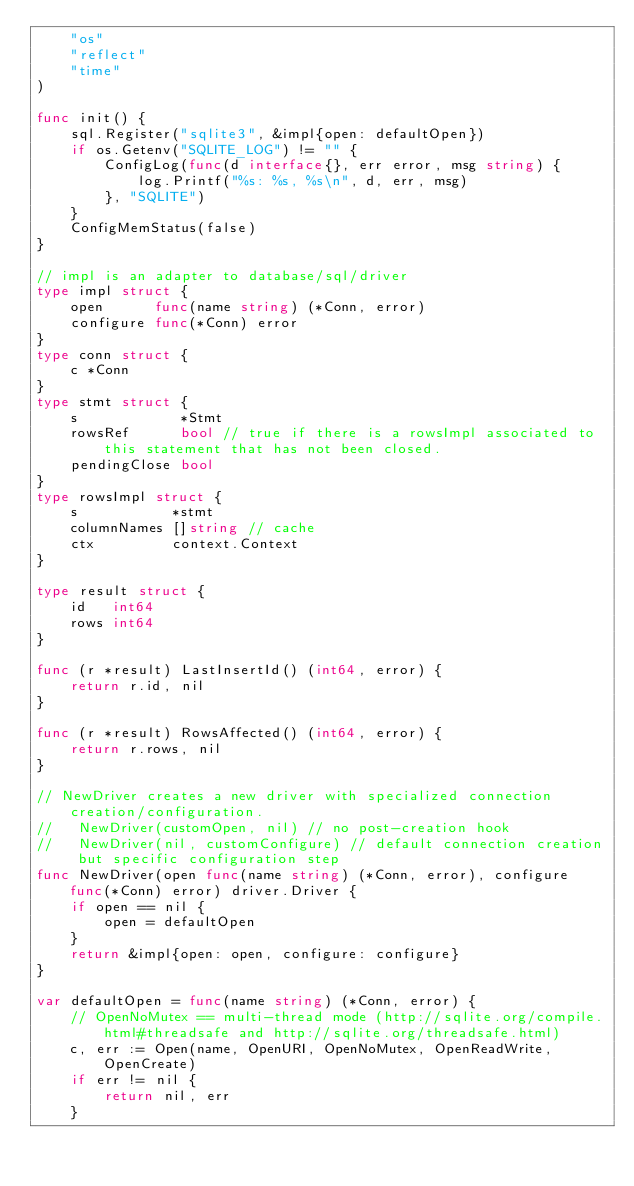<code> <loc_0><loc_0><loc_500><loc_500><_Go_>	"os"
	"reflect"
	"time"
)

func init() {
	sql.Register("sqlite3", &impl{open: defaultOpen})
	if os.Getenv("SQLITE_LOG") != "" {
		ConfigLog(func(d interface{}, err error, msg string) {
			log.Printf("%s: %s, %s\n", d, err, msg)
		}, "SQLITE")
	}
	ConfigMemStatus(false)
}

// impl is an adapter to database/sql/driver
type impl struct {
	open      func(name string) (*Conn, error)
	configure func(*Conn) error
}
type conn struct {
	c *Conn
}
type stmt struct {
	s            *Stmt
	rowsRef      bool // true if there is a rowsImpl associated to this statement that has not been closed.
	pendingClose bool
}
type rowsImpl struct {
	s           *stmt
	columnNames []string // cache
	ctx         context.Context
}

type result struct {
	id   int64
	rows int64
}

func (r *result) LastInsertId() (int64, error) {
	return r.id, nil
}

func (r *result) RowsAffected() (int64, error) {
	return r.rows, nil
}

// NewDriver creates a new driver with specialized connection creation/configuration.
//   NewDriver(customOpen, nil) // no post-creation hook
//   NewDriver(nil, customConfigure) // default connection creation but specific configuration step
func NewDriver(open func(name string) (*Conn, error), configure func(*Conn) error) driver.Driver {
	if open == nil {
		open = defaultOpen
	}
	return &impl{open: open, configure: configure}
}

var defaultOpen = func(name string) (*Conn, error) {
	// OpenNoMutex == multi-thread mode (http://sqlite.org/compile.html#threadsafe and http://sqlite.org/threadsafe.html)
	c, err := Open(name, OpenURI, OpenNoMutex, OpenReadWrite, OpenCreate)
	if err != nil {
		return nil, err
	}</code> 